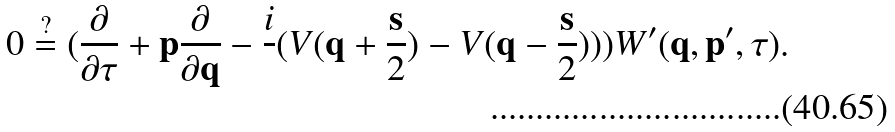Convert formula to latex. <formula><loc_0><loc_0><loc_500><loc_500>0 \stackrel { ? } = ( \frac { \partial } { \partial \tau } + { \mathbf p } \frac { \partial } { \partial { \mathbf q } } - \frac { i } { } ( V ( { \mathbf q } + \frac { \mathbf s } { 2 } ) - V ( { \mathbf q } - \frac { \mathbf s } { 2 } ) ) ) W ^ { \prime } ( { \mathbf q } , { \mathbf p } ^ { \prime } , \tau ) .</formula> 